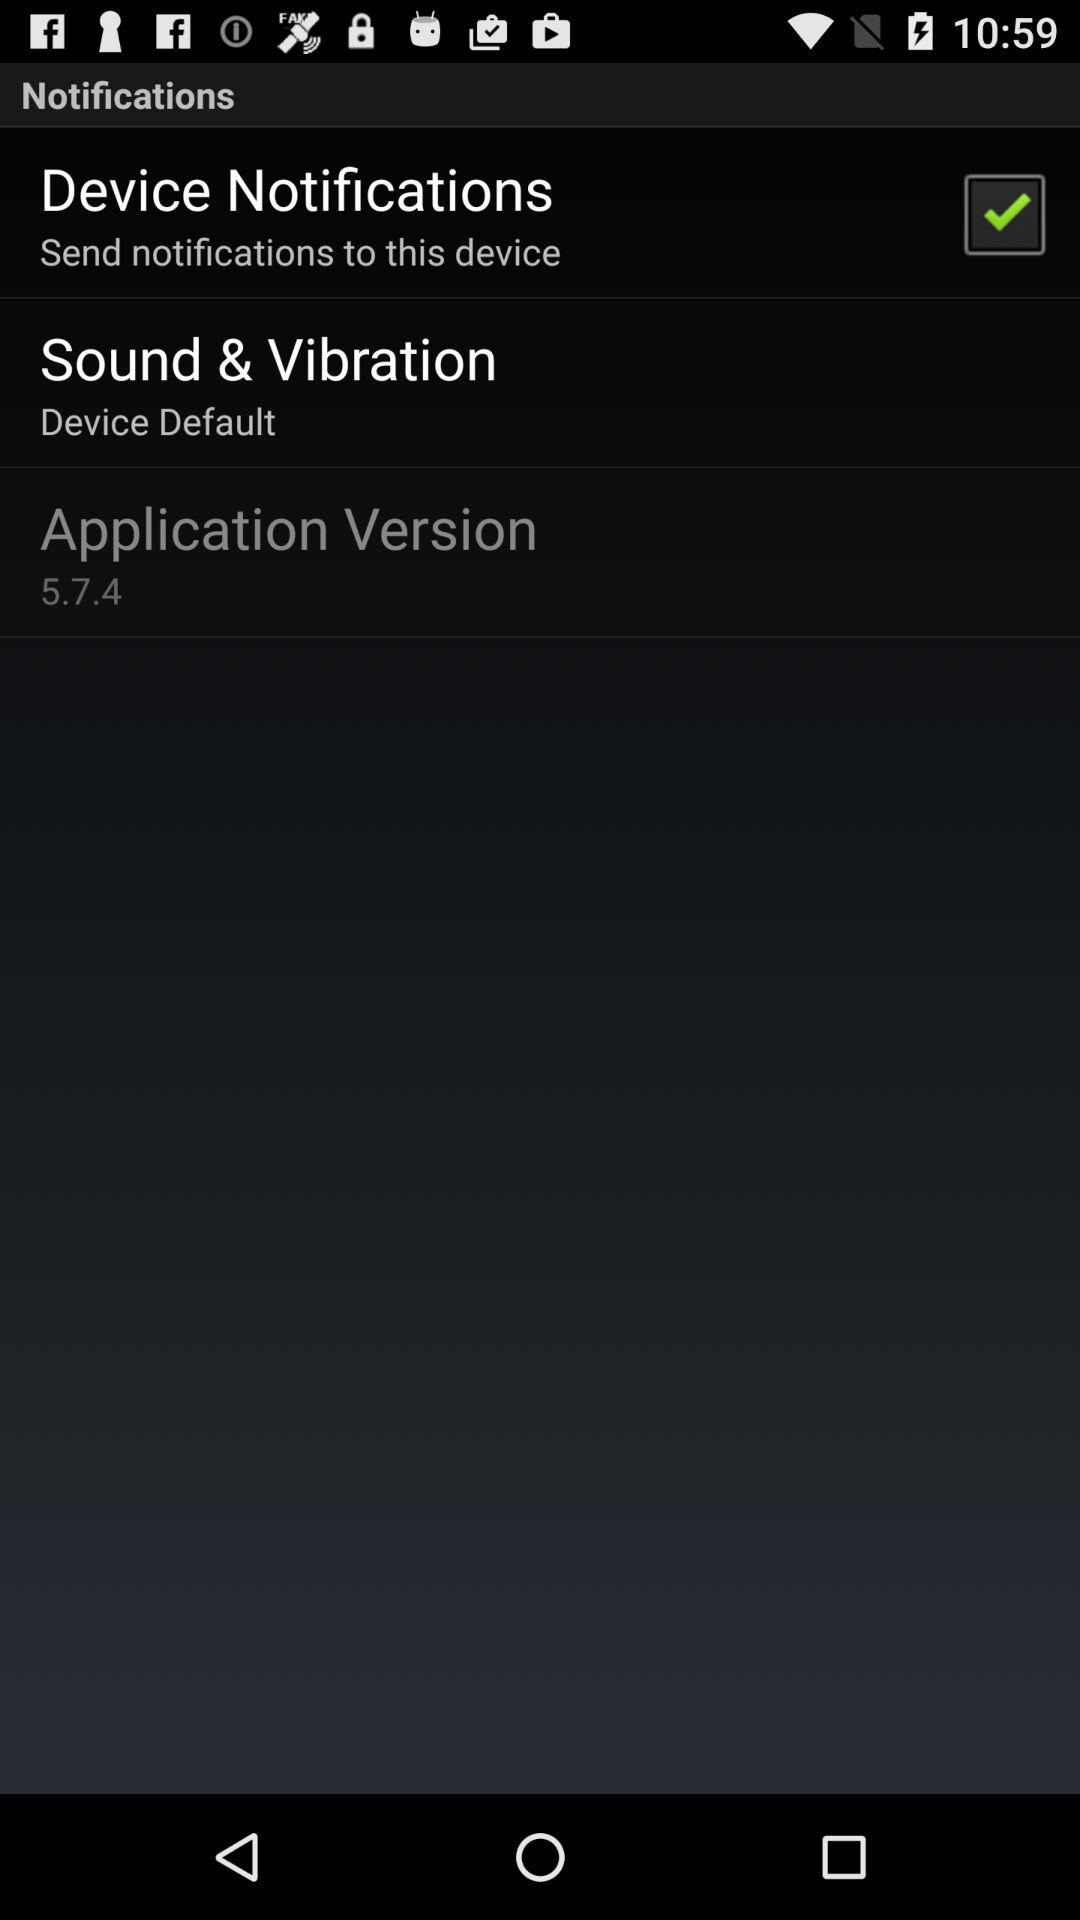What is the version of the application? The version of the application is 5.7.4. 